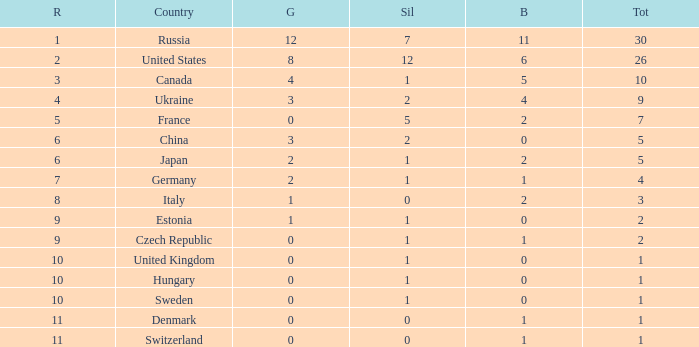How many silvers have a Nation of hungary, and a Rank larger than 10? 0.0. 